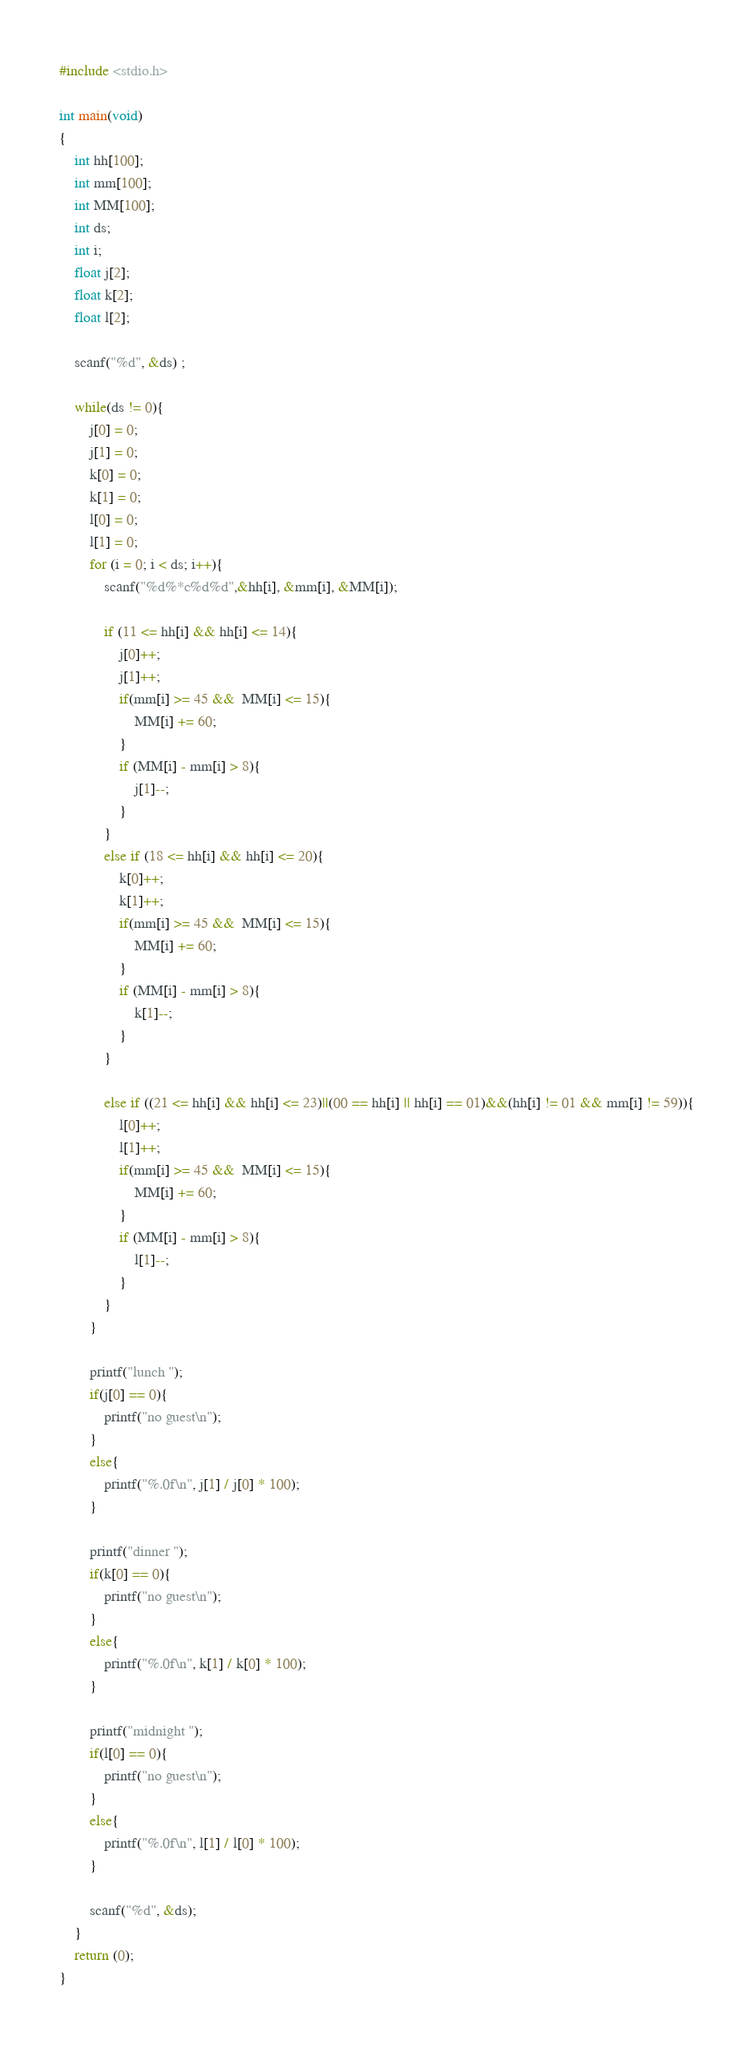<code> <loc_0><loc_0><loc_500><loc_500><_C_>#include <stdio.h>

int main(void)
{
	int hh[100];
	int mm[100];
	int MM[100];
	int ds;
	int i;
	float j[2];
	float k[2];
	float l[2];
	
	scanf("%d", &ds) ;
	
	while(ds != 0){
		j[0] = 0;
		j[1] = 0;
		k[0] = 0;
		k[1] = 0;
		l[0] = 0;
		l[1] = 0;
		for (i = 0; i < ds; i++){
			scanf("%d%*c%d%d",&hh[i], &mm[i], &MM[i]);
			
			if (11 <= hh[i] && hh[i] <= 14){
				j[0]++;
				j[1]++;
				if(mm[i] >= 45 &&  MM[i] <= 15){
					MM[i] += 60;
				}
				if (MM[i] - mm[i] > 8){
					j[1]--;
				}
			}
			else if (18 <= hh[i] && hh[i] <= 20){
				k[0]++;
				k[1]++;
				if(mm[i] >= 45 &&  MM[i] <= 15){
					MM[i] += 60;
				}
				if (MM[i] - mm[i] > 8){
					k[1]--;
				}
			}
			
			else if ((21 <= hh[i] && hh[i] <= 23)||(00 == hh[i] || hh[i] == 01)&&(hh[i] != 01 && mm[i] != 59)){
				l[0]++;
				l[1]++;
				if(mm[i] >= 45 &&  MM[i] <= 15){
					MM[i] += 60;
				}
				if (MM[i] - mm[i] > 8){
					l[1]--;
				}
			}
		}
		
		printf("lunch ");
		if(j[0] == 0){
			printf("no guest\n");
		}
		else{
			printf("%.0f\n", j[1] / j[0] * 100);
		}
		
		printf("dinner ");
		if(k[0] == 0){
			printf("no guest\n");
		}
		else{
			printf("%.0f\n", k[1] / k[0] * 100);
		}
		
		printf("midnight ");
		if(l[0] == 0){
			printf("no guest\n");
		}
		else{
			printf("%.0f\n", l[1] / l[0] * 100);
		}
		
		scanf("%d", &ds);
	}
	return (0);
}</code> 